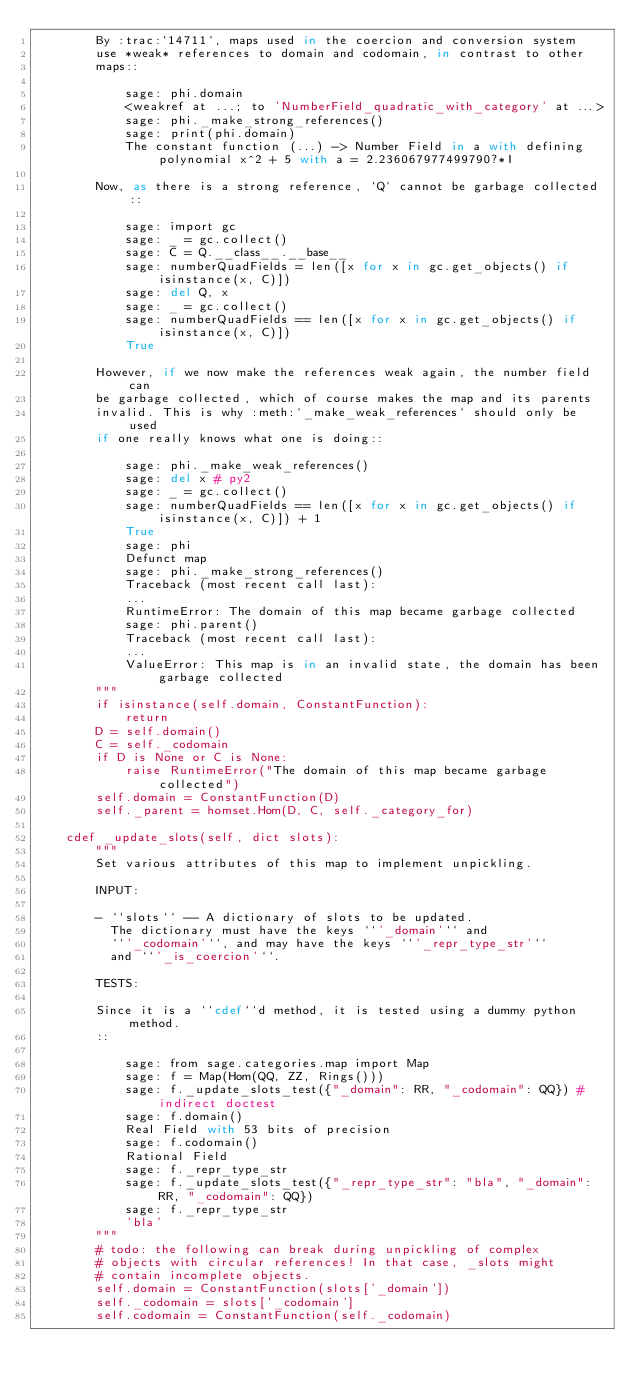Convert code to text. <code><loc_0><loc_0><loc_500><loc_500><_Cython_>        By :trac:`14711`, maps used in the coercion and conversion system
        use *weak* references to domain and codomain, in contrast to other
        maps::

            sage: phi.domain
            <weakref at ...; to 'NumberField_quadratic_with_category' at ...>
            sage: phi._make_strong_references()
            sage: print(phi.domain)
            The constant function (...) -> Number Field in a with defining polynomial x^2 + 5 with a = 2.236067977499790?*I

        Now, as there is a strong reference, `Q` cannot be garbage collected::

            sage: import gc
            sage: _ = gc.collect()
            sage: C = Q.__class__.__base__
            sage: numberQuadFields = len([x for x in gc.get_objects() if isinstance(x, C)])
            sage: del Q, x
            sage: _ = gc.collect()
            sage: numberQuadFields == len([x for x in gc.get_objects() if isinstance(x, C)])
            True

        However, if we now make the references weak again, the number field can
        be garbage collected, which of course makes the map and its parents
        invalid. This is why :meth:`_make_weak_references` should only be used
        if one really knows what one is doing::

            sage: phi._make_weak_references()
            sage: del x # py2
            sage: _ = gc.collect()
            sage: numberQuadFields == len([x for x in gc.get_objects() if isinstance(x, C)]) + 1
            True
            sage: phi
            Defunct map
            sage: phi._make_strong_references()
            Traceback (most recent call last):
            ...
            RuntimeError: The domain of this map became garbage collected
            sage: phi.parent()
            Traceback (most recent call last):
            ...
            ValueError: This map is in an invalid state, the domain has been garbage collected
        """
        if isinstance(self.domain, ConstantFunction):
            return
        D = self.domain()
        C = self._codomain
        if D is None or C is None:
            raise RuntimeError("The domain of this map became garbage collected")
        self.domain = ConstantFunction(D)
        self._parent = homset.Hom(D, C, self._category_for)

    cdef _update_slots(self, dict slots):
        """
        Set various attributes of this map to implement unpickling.

        INPUT:

        - ``slots`` -- A dictionary of slots to be updated.
          The dictionary must have the keys ``'_domain'`` and
          ``'_codomain'``, and may have the keys ``'_repr_type_str'``
          and ``'_is_coercion'``.

        TESTS:

        Since it is a ``cdef``d method, it is tested using a dummy python method.
        ::

            sage: from sage.categories.map import Map
            sage: f = Map(Hom(QQ, ZZ, Rings()))
            sage: f._update_slots_test({"_domain": RR, "_codomain": QQ}) # indirect doctest
            sage: f.domain()
            Real Field with 53 bits of precision
            sage: f.codomain()
            Rational Field
            sage: f._repr_type_str
            sage: f._update_slots_test({"_repr_type_str": "bla", "_domain": RR, "_codomain": QQ})
            sage: f._repr_type_str
            'bla'
        """
        # todo: the following can break during unpickling of complex
        # objects with circular references! In that case, _slots might
        # contain incomplete objects.
        self.domain = ConstantFunction(slots['_domain'])
        self._codomain = slots['_codomain']
        self.codomain = ConstantFunction(self._codomain)
</code> 